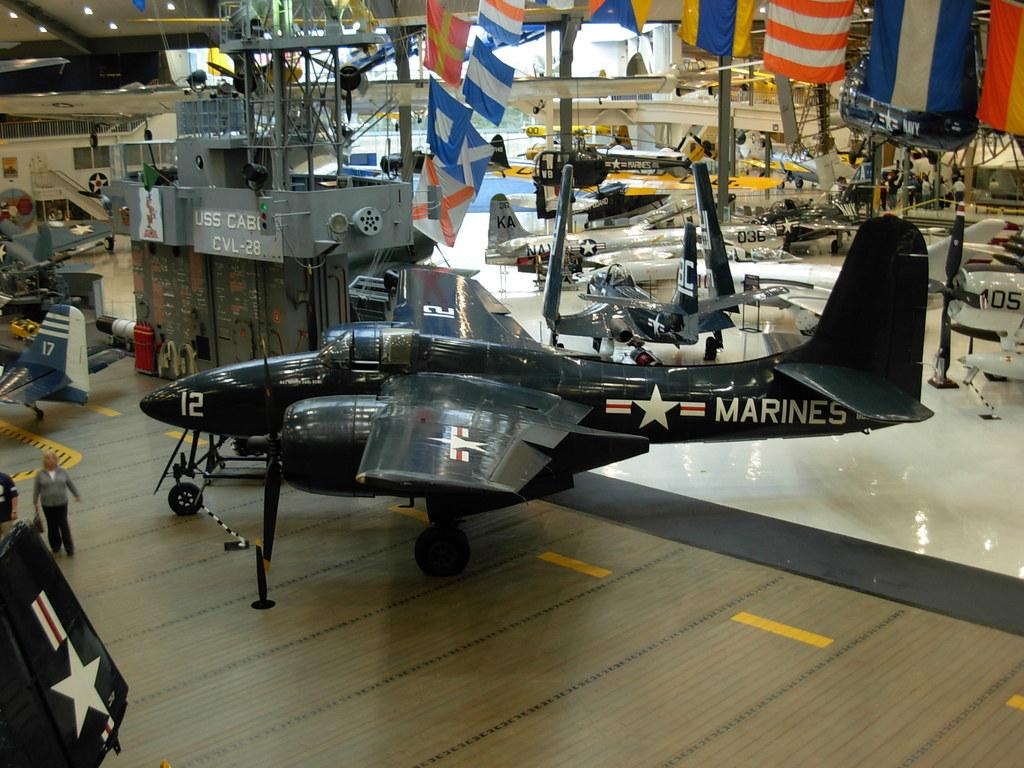<image>
Summarize the visual content of the image. a small dark plane inside of a building on display with the # 12 and MARINES on it. 